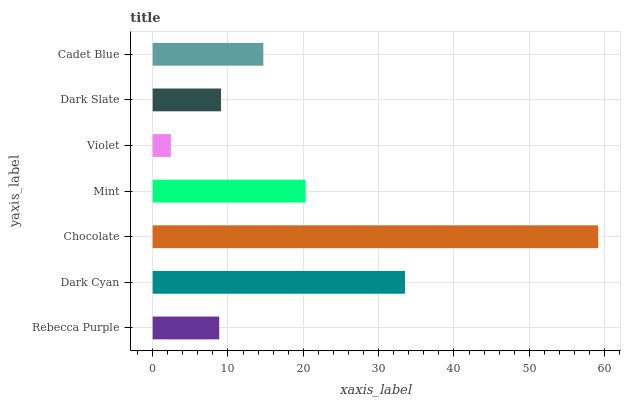Is Violet the minimum?
Answer yes or no. Yes. Is Chocolate the maximum?
Answer yes or no. Yes. Is Dark Cyan the minimum?
Answer yes or no. No. Is Dark Cyan the maximum?
Answer yes or no. No. Is Dark Cyan greater than Rebecca Purple?
Answer yes or no. Yes. Is Rebecca Purple less than Dark Cyan?
Answer yes or no. Yes. Is Rebecca Purple greater than Dark Cyan?
Answer yes or no. No. Is Dark Cyan less than Rebecca Purple?
Answer yes or no. No. Is Cadet Blue the high median?
Answer yes or no. Yes. Is Cadet Blue the low median?
Answer yes or no. Yes. Is Violet the high median?
Answer yes or no. No. Is Mint the low median?
Answer yes or no. No. 